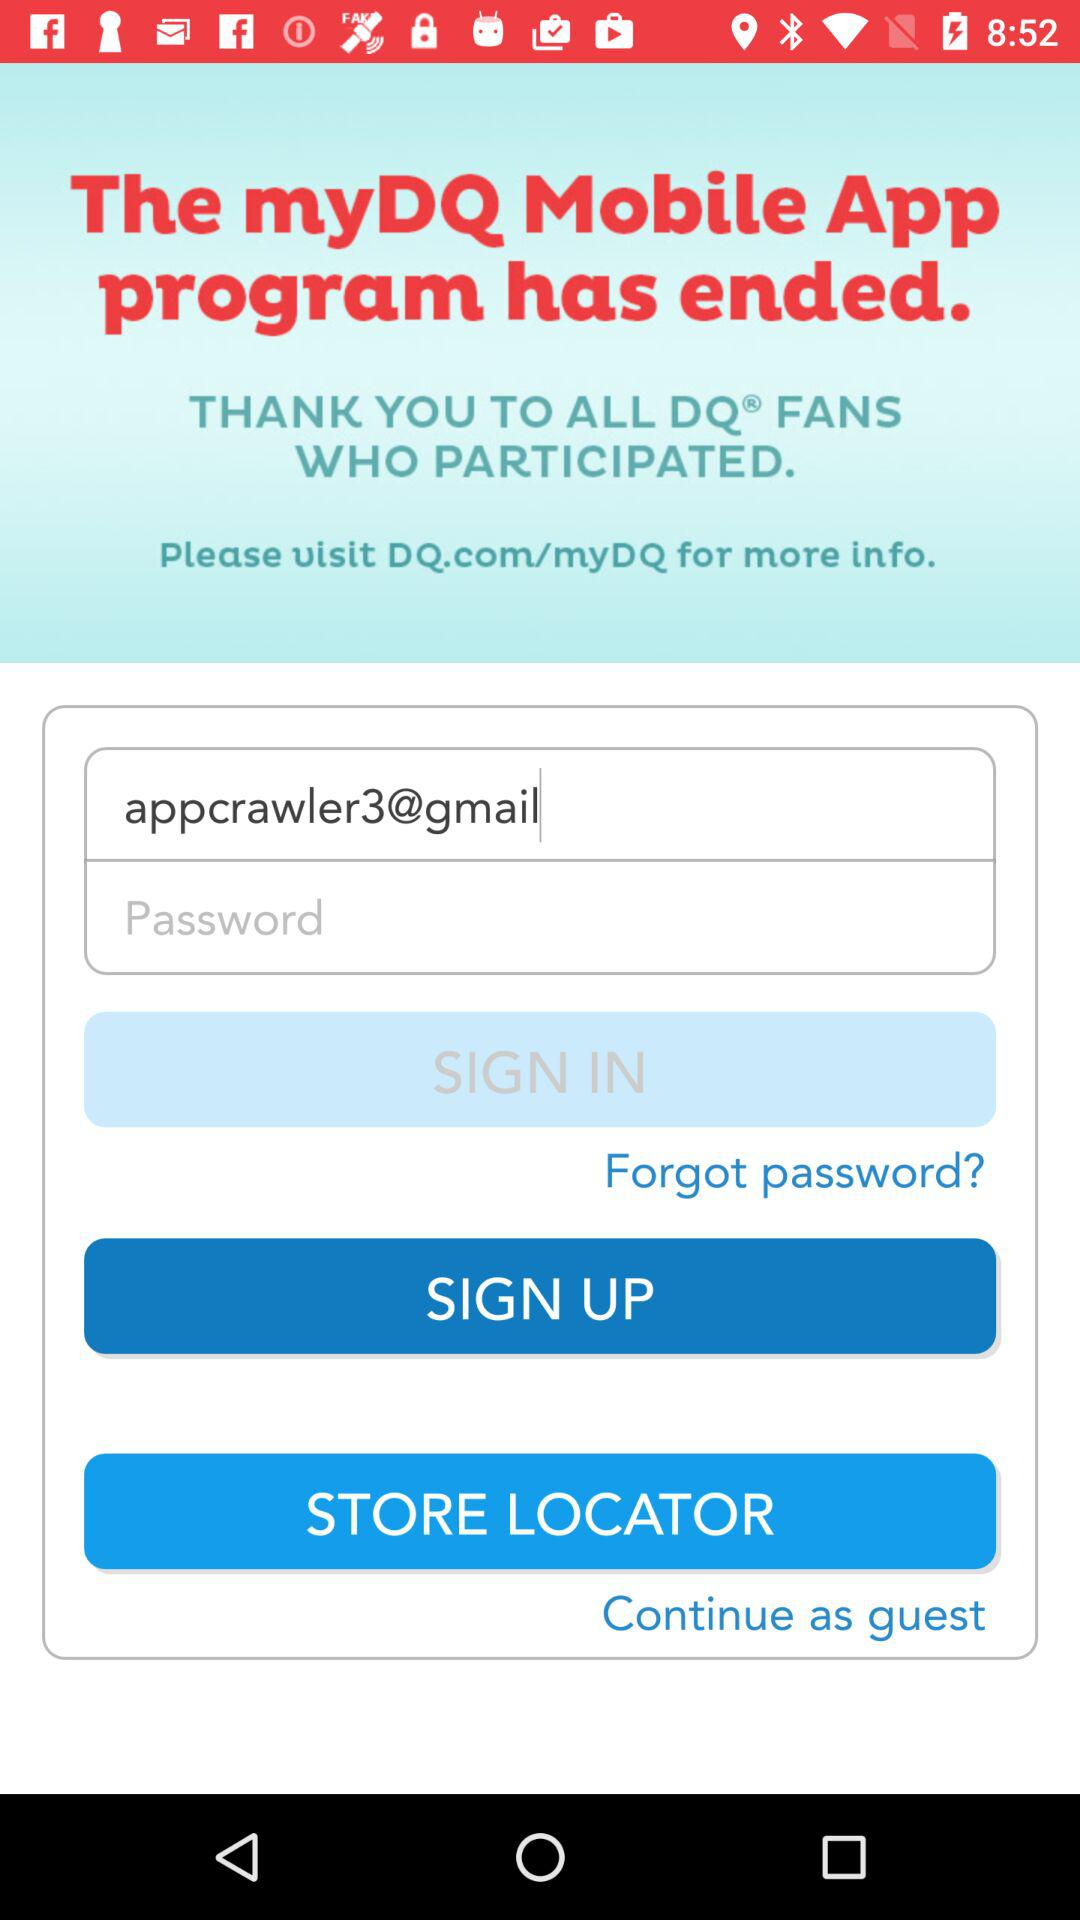What are the requirements to get a sign-in?
When the provided information is insufficient, respond with <no answer>. <no answer> 